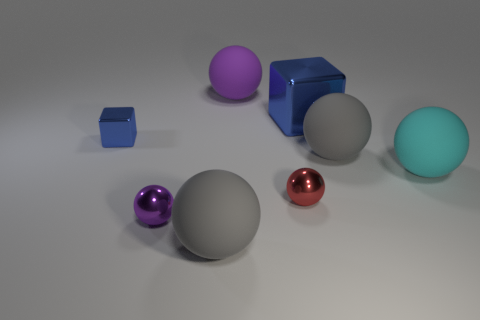There is a gray object that is to the right of the blue metallic object right of the large matte ball in front of the cyan thing; what is its size? The gray object to the right of the blue metallic cube, situated to the right of the large matte gray sphere and in front of the cyan object, is relatively small in size, particularly when compared to the larger balls and cubes in the scene. It appears to be a smaller version of the gray sphere, providing a sense of scale within the image. 